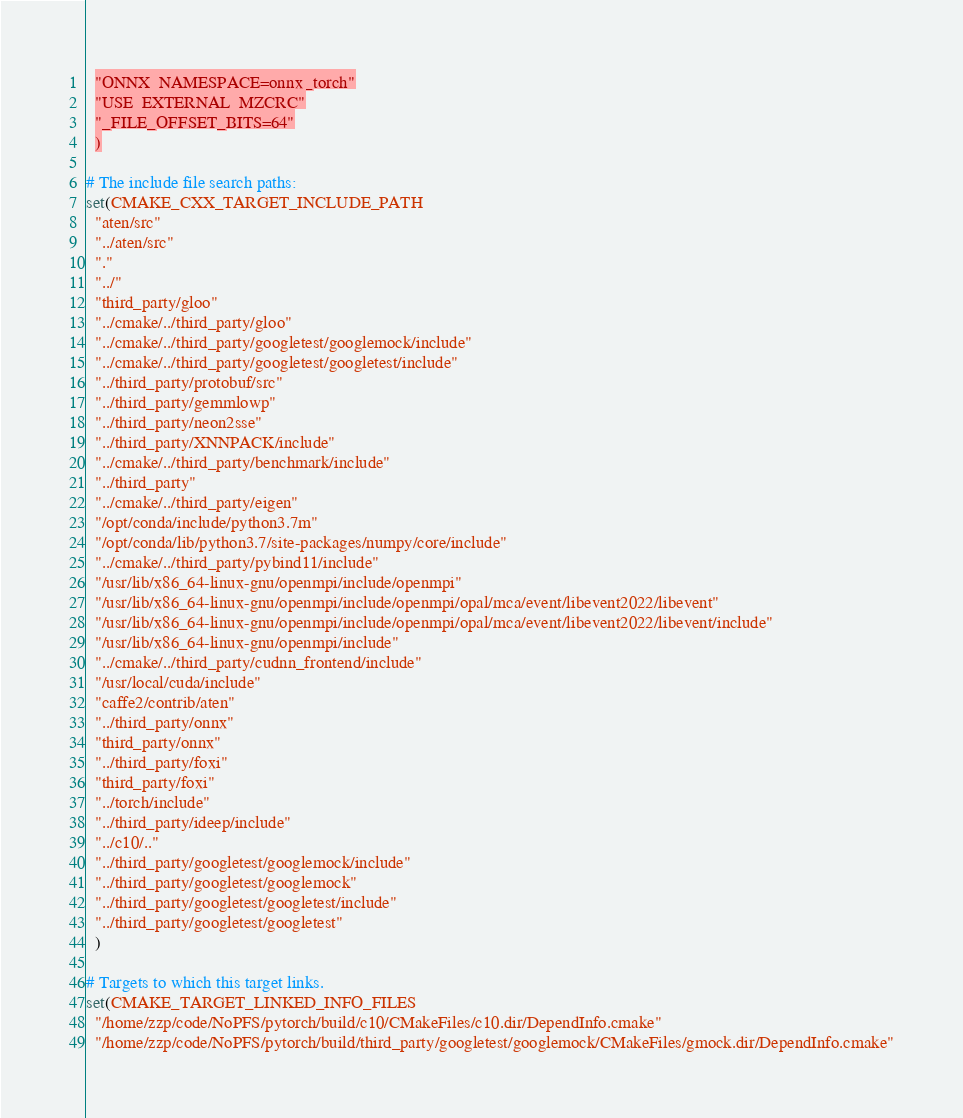<code> <loc_0><loc_0><loc_500><loc_500><_CMake_>  "ONNX_NAMESPACE=onnx_torch"
  "USE_EXTERNAL_MZCRC"
  "_FILE_OFFSET_BITS=64"
  )

# The include file search paths:
set(CMAKE_CXX_TARGET_INCLUDE_PATH
  "aten/src"
  "../aten/src"
  "."
  "../"
  "third_party/gloo"
  "../cmake/../third_party/gloo"
  "../cmake/../third_party/googletest/googlemock/include"
  "../cmake/../third_party/googletest/googletest/include"
  "../third_party/protobuf/src"
  "../third_party/gemmlowp"
  "../third_party/neon2sse"
  "../third_party/XNNPACK/include"
  "../cmake/../third_party/benchmark/include"
  "../third_party"
  "../cmake/../third_party/eigen"
  "/opt/conda/include/python3.7m"
  "/opt/conda/lib/python3.7/site-packages/numpy/core/include"
  "../cmake/../third_party/pybind11/include"
  "/usr/lib/x86_64-linux-gnu/openmpi/include/openmpi"
  "/usr/lib/x86_64-linux-gnu/openmpi/include/openmpi/opal/mca/event/libevent2022/libevent"
  "/usr/lib/x86_64-linux-gnu/openmpi/include/openmpi/opal/mca/event/libevent2022/libevent/include"
  "/usr/lib/x86_64-linux-gnu/openmpi/include"
  "../cmake/../third_party/cudnn_frontend/include"
  "/usr/local/cuda/include"
  "caffe2/contrib/aten"
  "../third_party/onnx"
  "third_party/onnx"
  "../third_party/foxi"
  "third_party/foxi"
  "../torch/include"
  "../third_party/ideep/include"
  "../c10/.."
  "../third_party/googletest/googlemock/include"
  "../third_party/googletest/googlemock"
  "../third_party/googletest/googletest/include"
  "../third_party/googletest/googletest"
  )

# Targets to which this target links.
set(CMAKE_TARGET_LINKED_INFO_FILES
  "/home/zzp/code/NoPFS/pytorch/build/c10/CMakeFiles/c10.dir/DependInfo.cmake"
  "/home/zzp/code/NoPFS/pytorch/build/third_party/googletest/googlemock/CMakeFiles/gmock.dir/DependInfo.cmake"</code> 